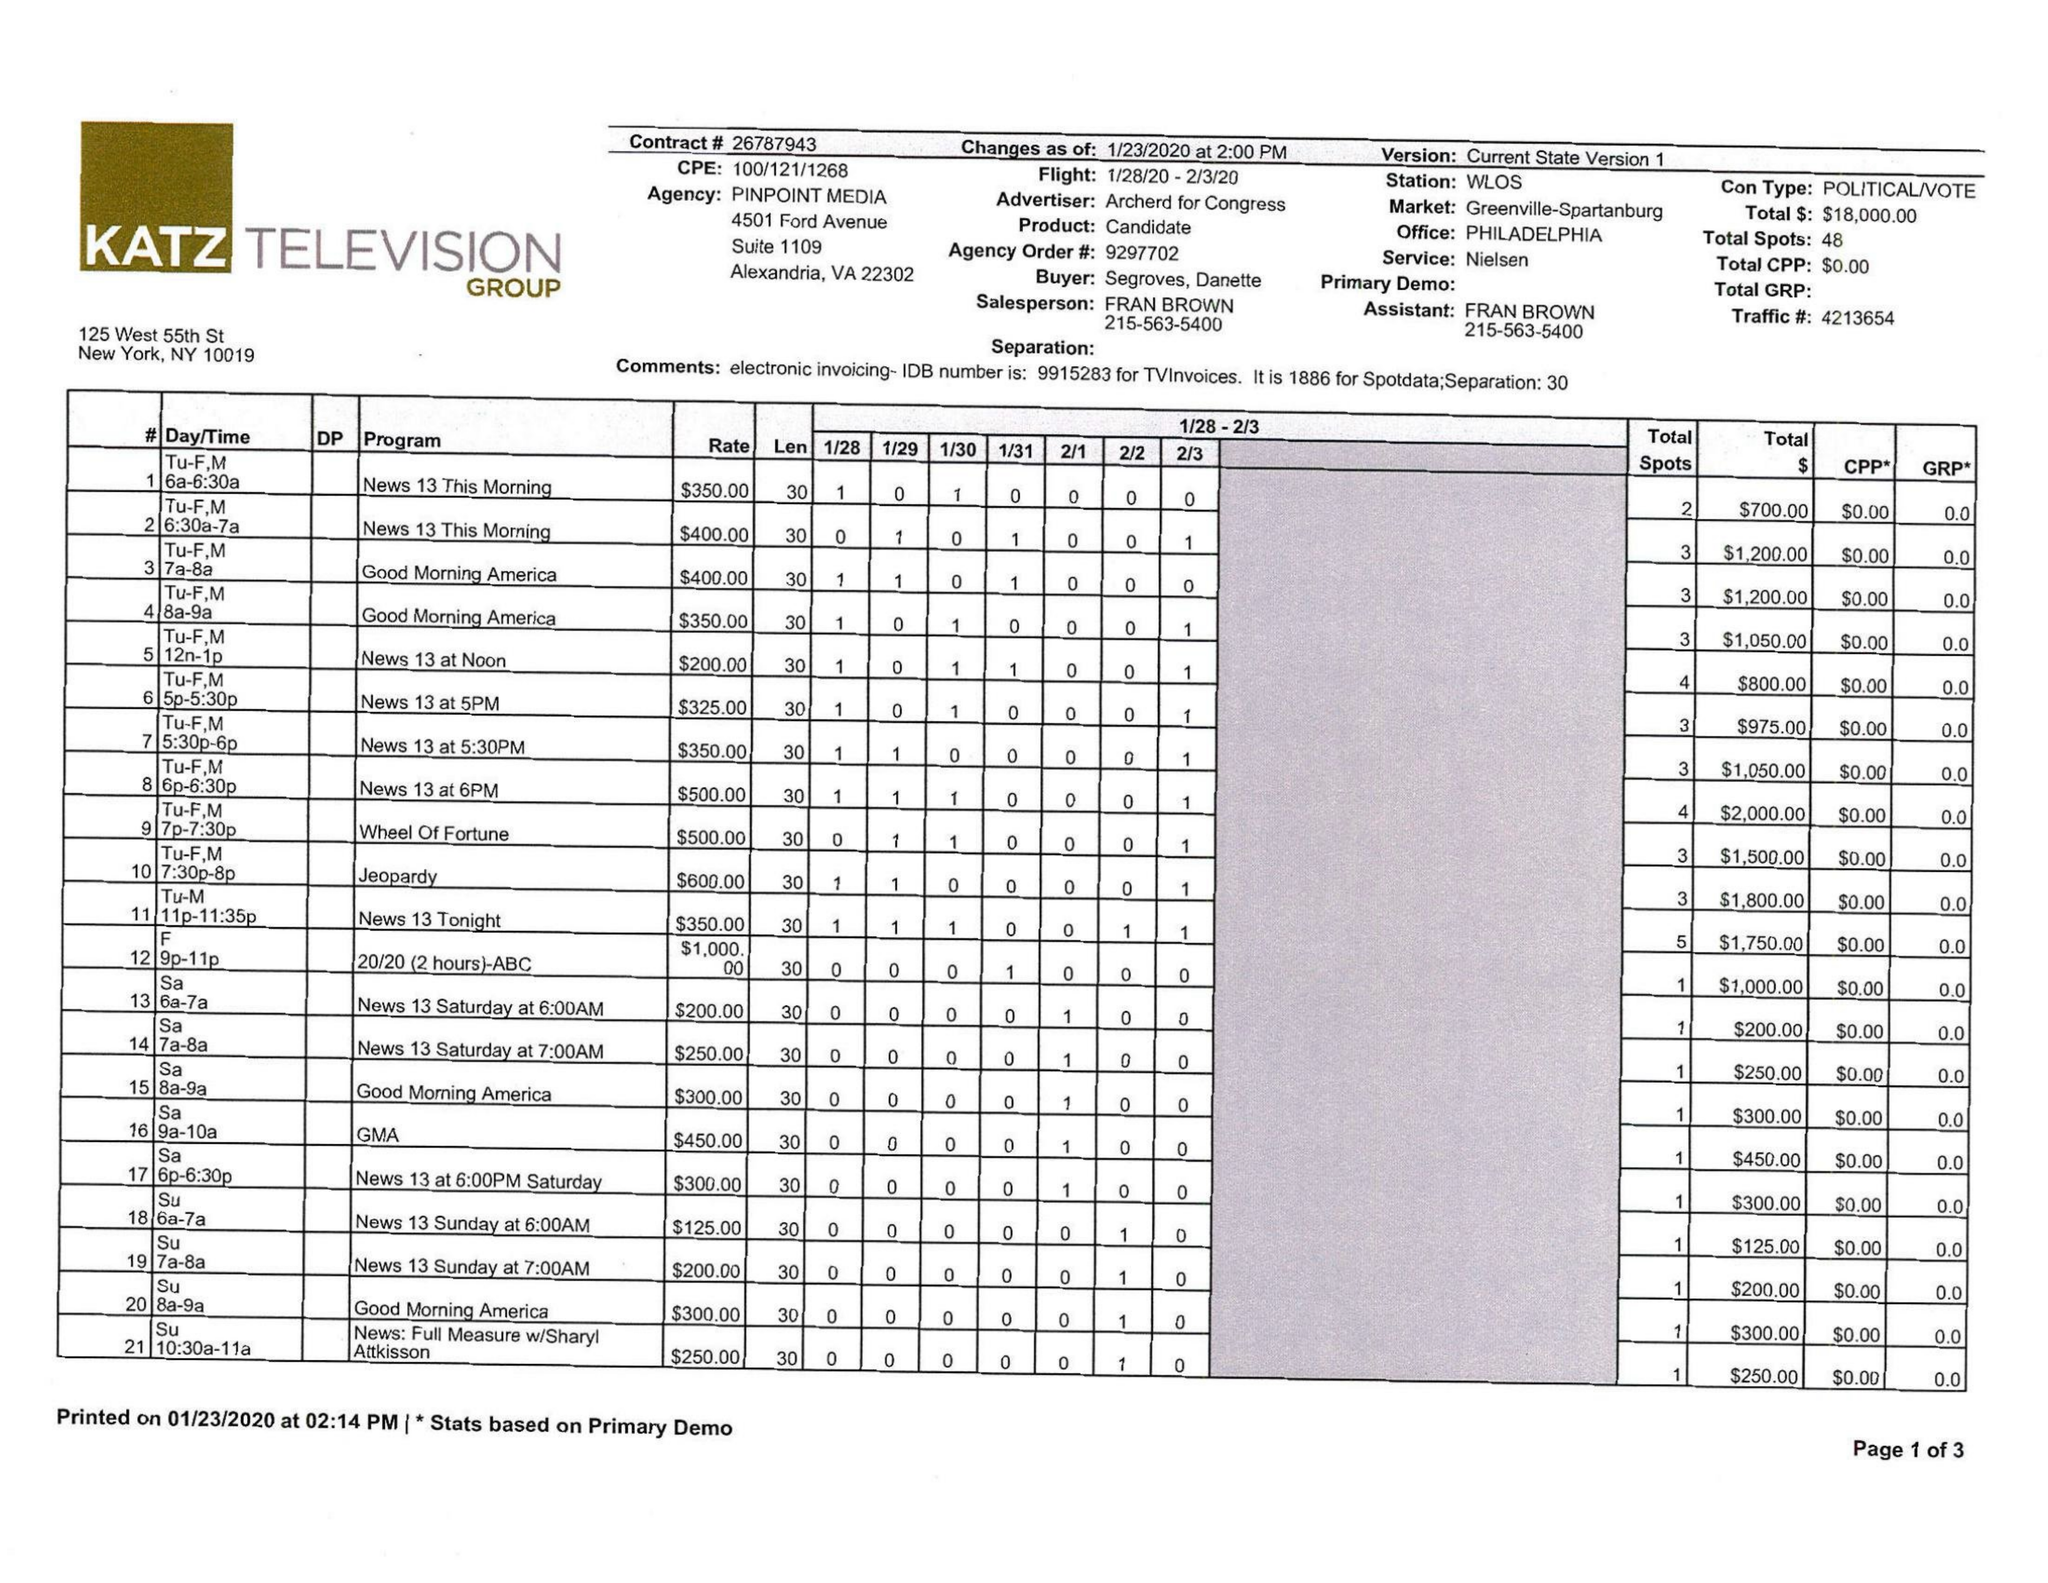What is the value for the gross_amount?
Answer the question using a single word or phrase. 18000.00 